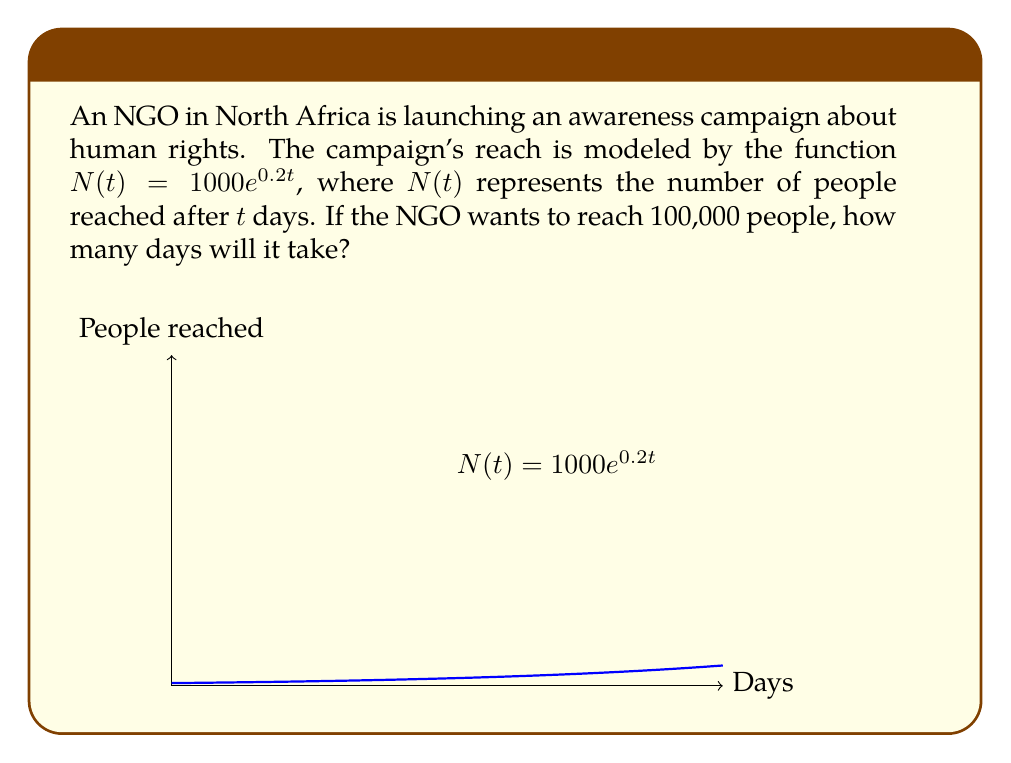Could you help me with this problem? To solve this problem, we need to use the exponential growth model and logarithms. Let's approach this step-by-step:

1) We start with the equation $N(t) = 1000e^{0.2t}$

2) We want to find $t$ when $N(t) = 100,000$. So, let's set up the equation:

   $100,000 = 1000e^{0.2t}$

3) Divide both sides by 1000:

   $100 = e^{0.2t}$

4) Now, we need to solve for $t$. We can do this by taking the natural logarithm of both sides:

   $\ln(100) = \ln(e^{0.2t})$

5) The right side simplifies due to the properties of logarithms:

   $\ln(100) = 0.2t$

6) Now we can solve for $t$:

   $t = \frac{\ln(100)}{0.2}$

7) Calculate this value:

   $t = \frac{4.60517}{0.2} = 23.02585$

8) Since we're dealing with days, we need to round up to the nearest whole day.

Therefore, it will take 24 days for the campaign to reach 100,000 people.
Answer: 24 days 